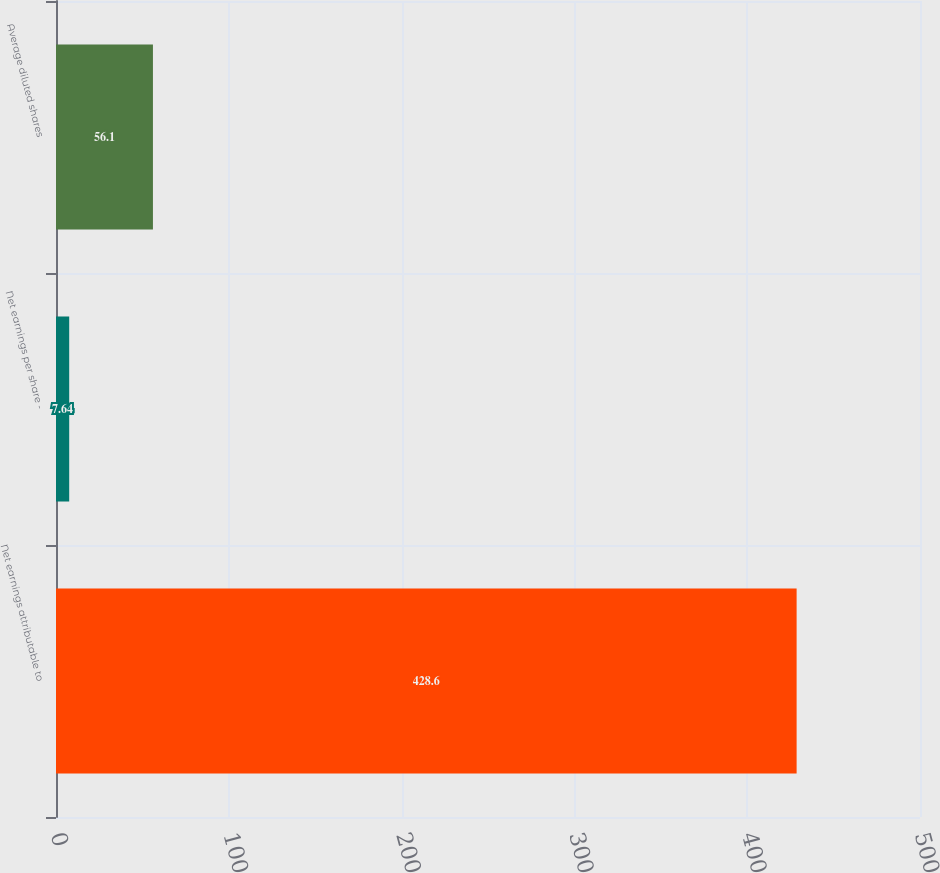Convert chart to OTSL. <chart><loc_0><loc_0><loc_500><loc_500><bar_chart><fcel>Net earnings attributable to<fcel>Net earnings per share -<fcel>Average diluted shares<nl><fcel>428.6<fcel>7.64<fcel>56.1<nl></chart> 